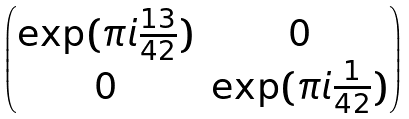Convert formula to latex. <formula><loc_0><loc_0><loc_500><loc_500>\begin{pmatrix} \exp ( \pi i \frac { 1 3 } { 4 2 } ) & 0 \\ 0 & \exp ( \pi i \frac { 1 } { 4 2 } ) \end{pmatrix}</formula> 